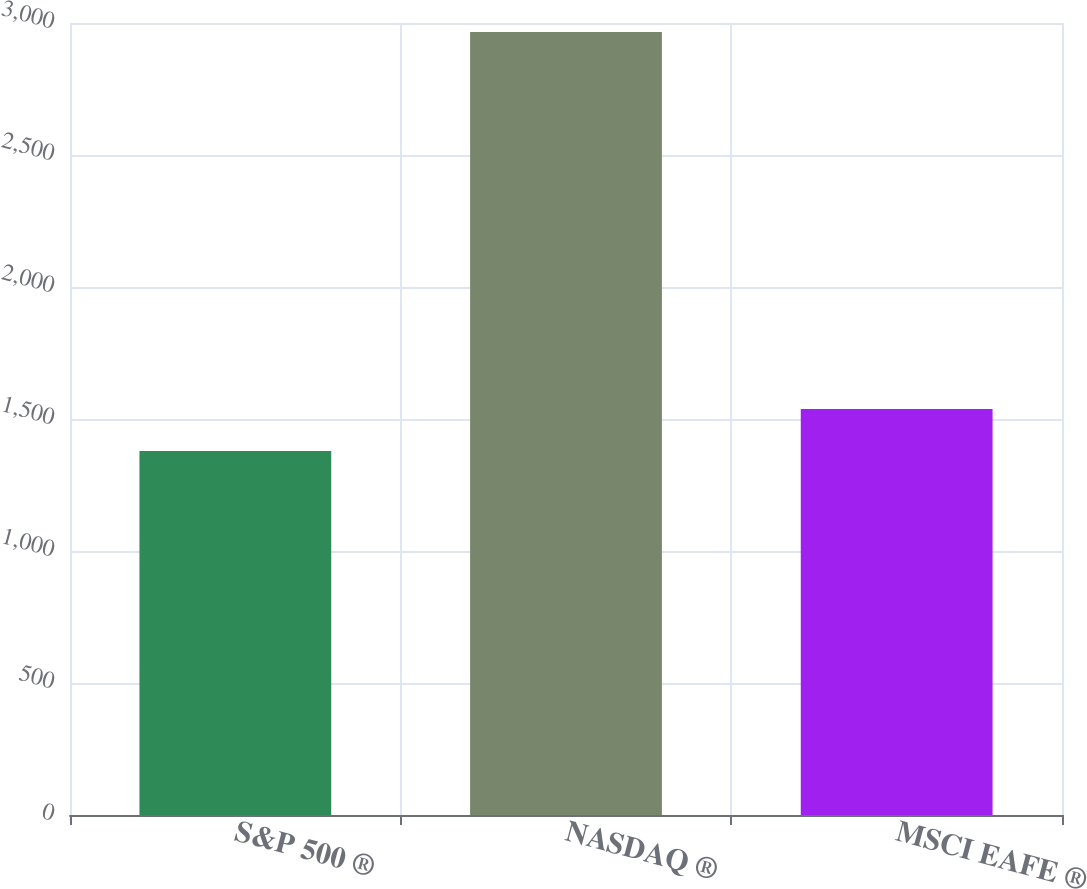<chart> <loc_0><loc_0><loc_500><loc_500><bar_chart><fcel>S&P 500 ®<fcel>NASDAQ ®<fcel>MSCI EAFE ®<nl><fcel>1379<fcel>2966<fcel>1537.7<nl></chart> 